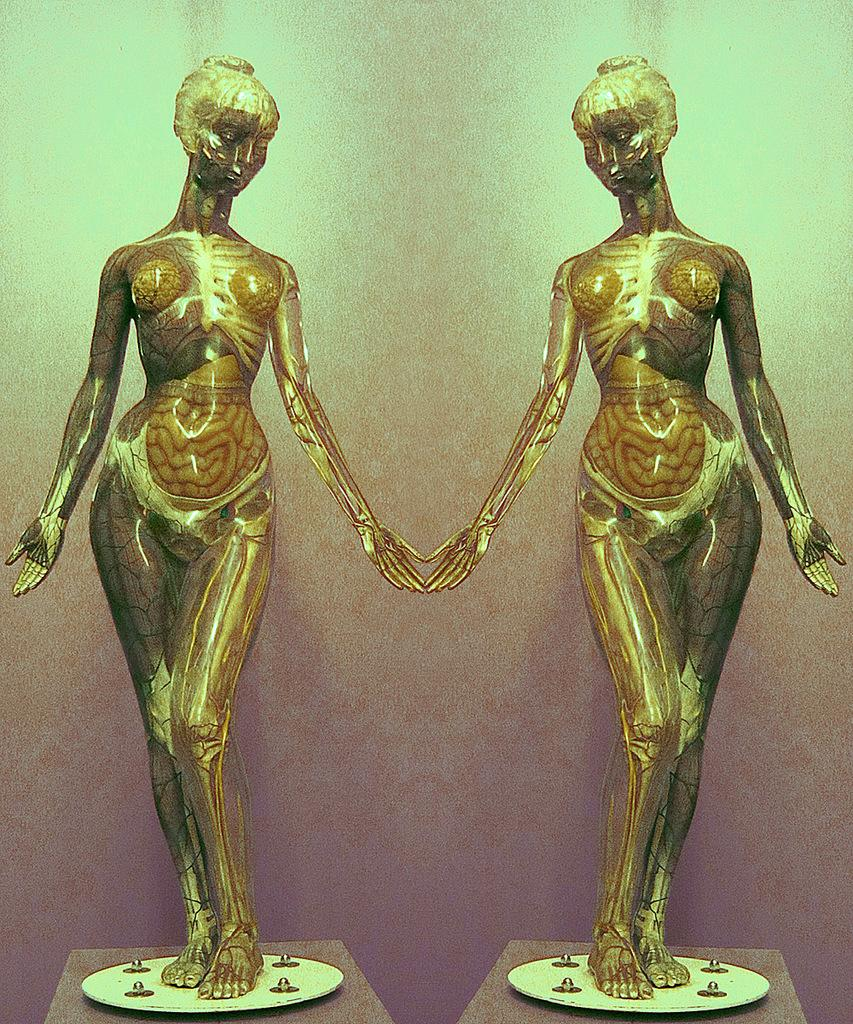What type of art can be seen in the image? There are sculptures in the image. Can you describe the sculptures in more detail? Unfortunately, the facts provided do not give any specific details about the sculptures. Where might these sculptures be located? The location of the sculptures cannot be determined from the provided facts. Is there a water fountain bubbling in the background of the image? There is no mention of a water fountain or bubbling in the provided facts, so it cannot be determined from the image. 